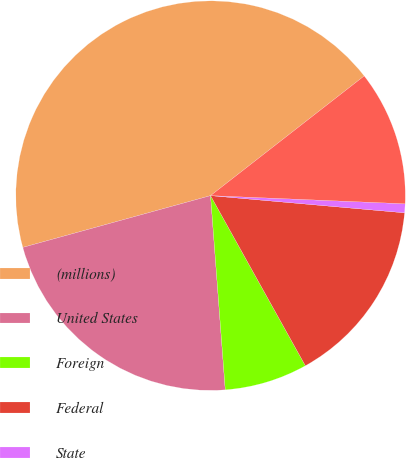<chart> <loc_0><loc_0><loc_500><loc_500><pie_chart><fcel>(millions)<fcel>United States<fcel>Foreign<fcel>Federal<fcel>State<fcel>Total income taxes<nl><fcel>43.75%<fcel>21.92%<fcel>6.89%<fcel>15.5%<fcel>0.74%<fcel>11.2%<nl></chart> 